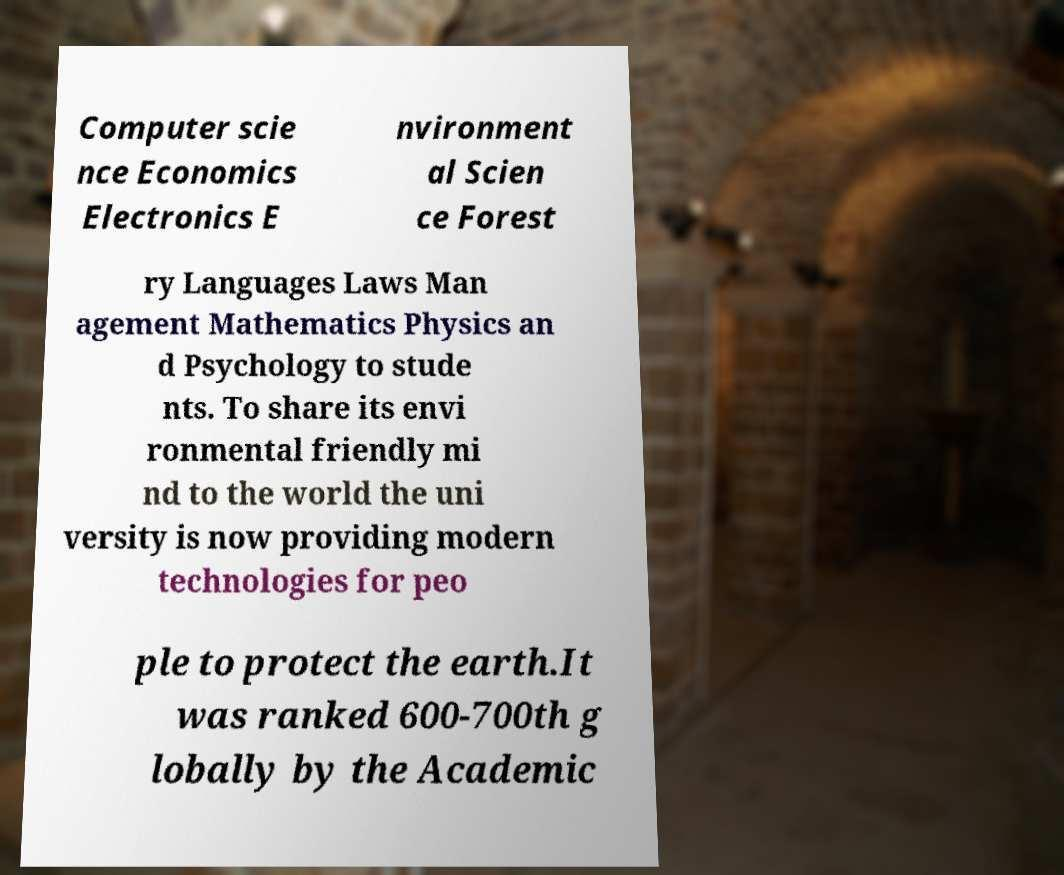What messages or text are displayed in this image? I need them in a readable, typed format. Computer scie nce Economics Electronics E nvironment al Scien ce Forest ry Languages Laws Man agement Mathematics Physics an d Psychology to stude nts. To share its envi ronmental friendly mi nd to the world the uni versity is now providing modern technologies for peo ple to protect the earth.It was ranked 600-700th g lobally by the Academic 